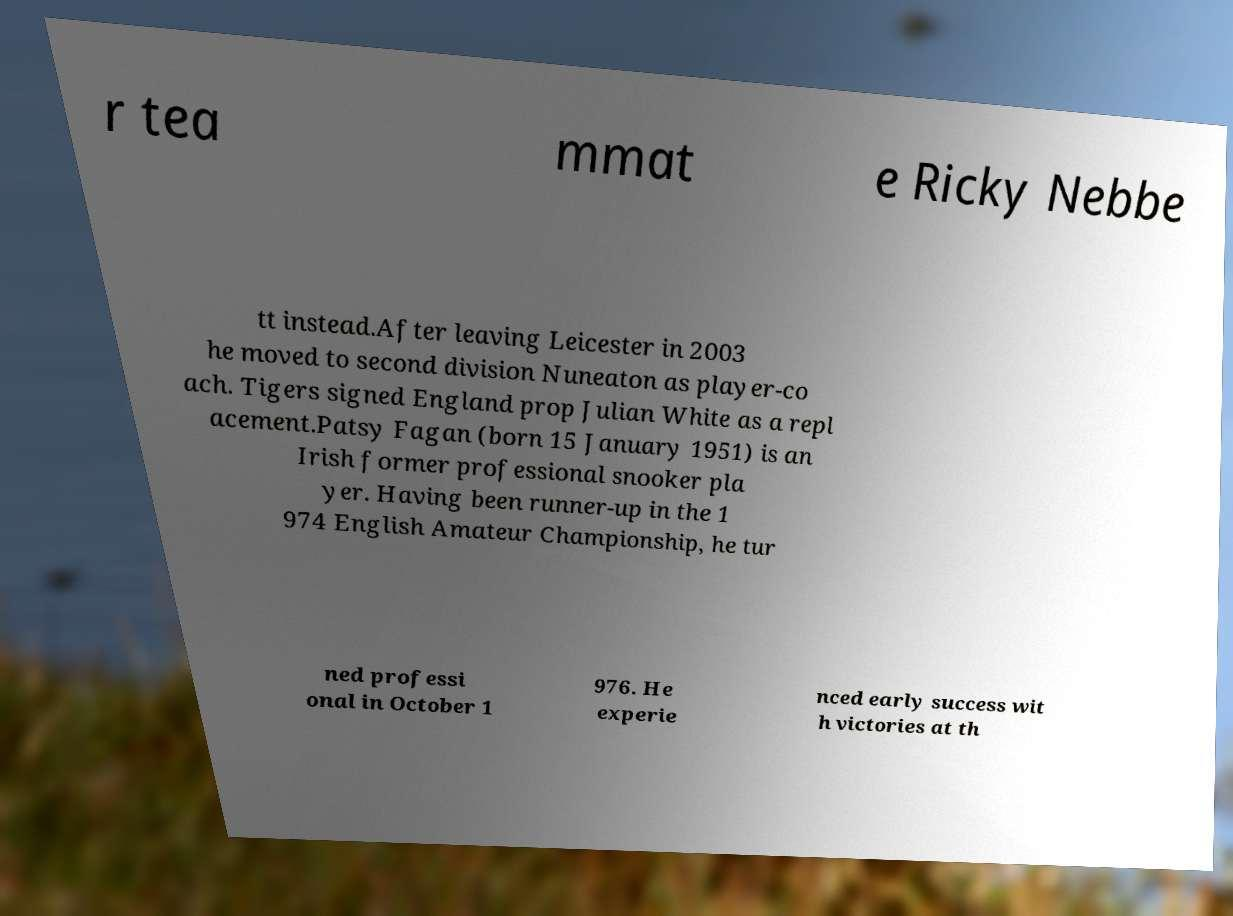Can you read and provide the text displayed in the image?This photo seems to have some interesting text. Can you extract and type it out for me? r tea mmat e Ricky Nebbe tt instead.After leaving Leicester in 2003 he moved to second division Nuneaton as player-co ach. Tigers signed England prop Julian White as a repl acement.Patsy Fagan (born 15 January 1951) is an Irish former professional snooker pla yer. Having been runner-up in the 1 974 English Amateur Championship, he tur ned professi onal in October 1 976. He experie nced early success wit h victories at th 